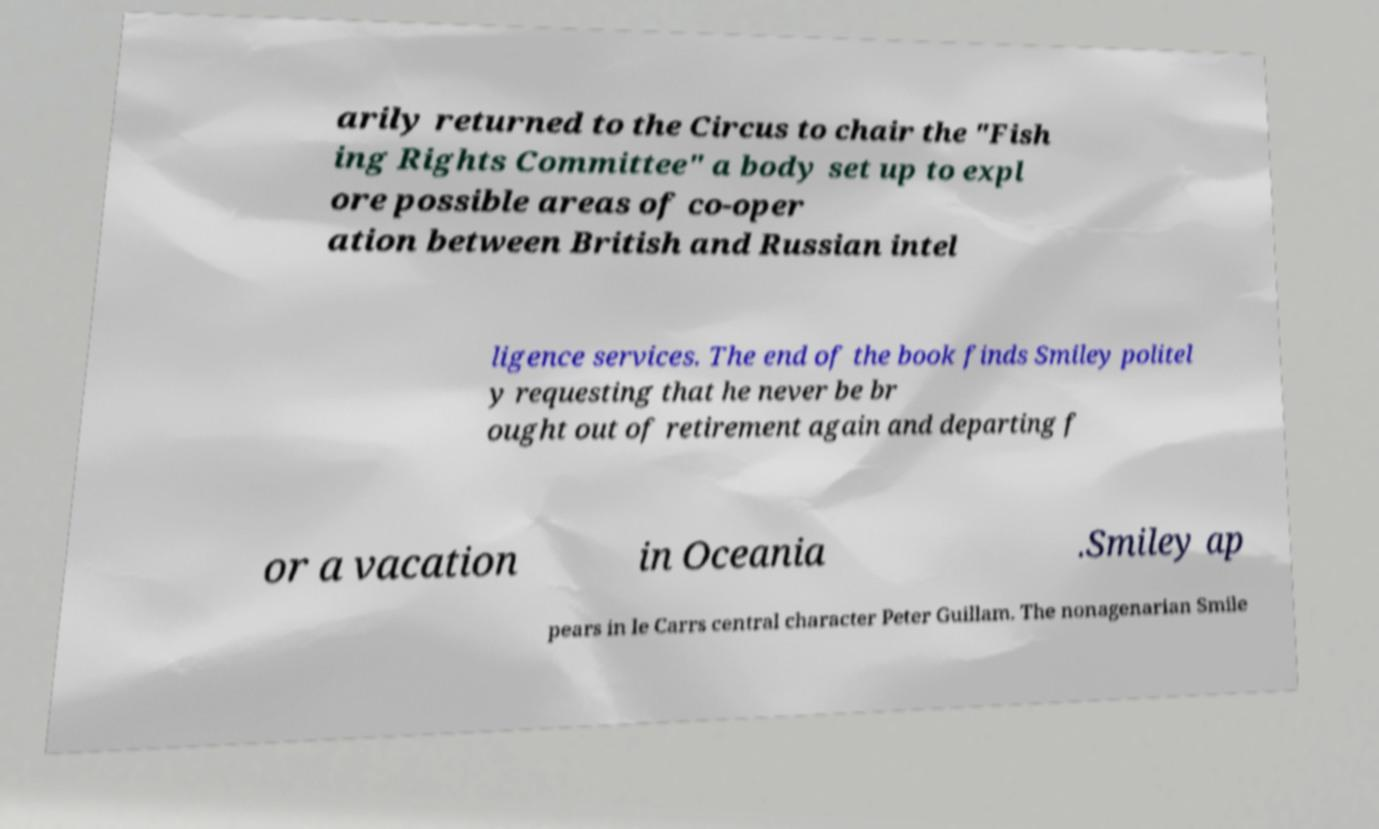I need the written content from this picture converted into text. Can you do that? arily returned to the Circus to chair the "Fish ing Rights Committee" a body set up to expl ore possible areas of co-oper ation between British and Russian intel ligence services. The end of the book finds Smiley politel y requesting that he never be br ought out of retirement again and departing f or a vacation in Oceania .Smiley ap pears in le Carrs central character Peter Guillam. The nonagenarian Smile 